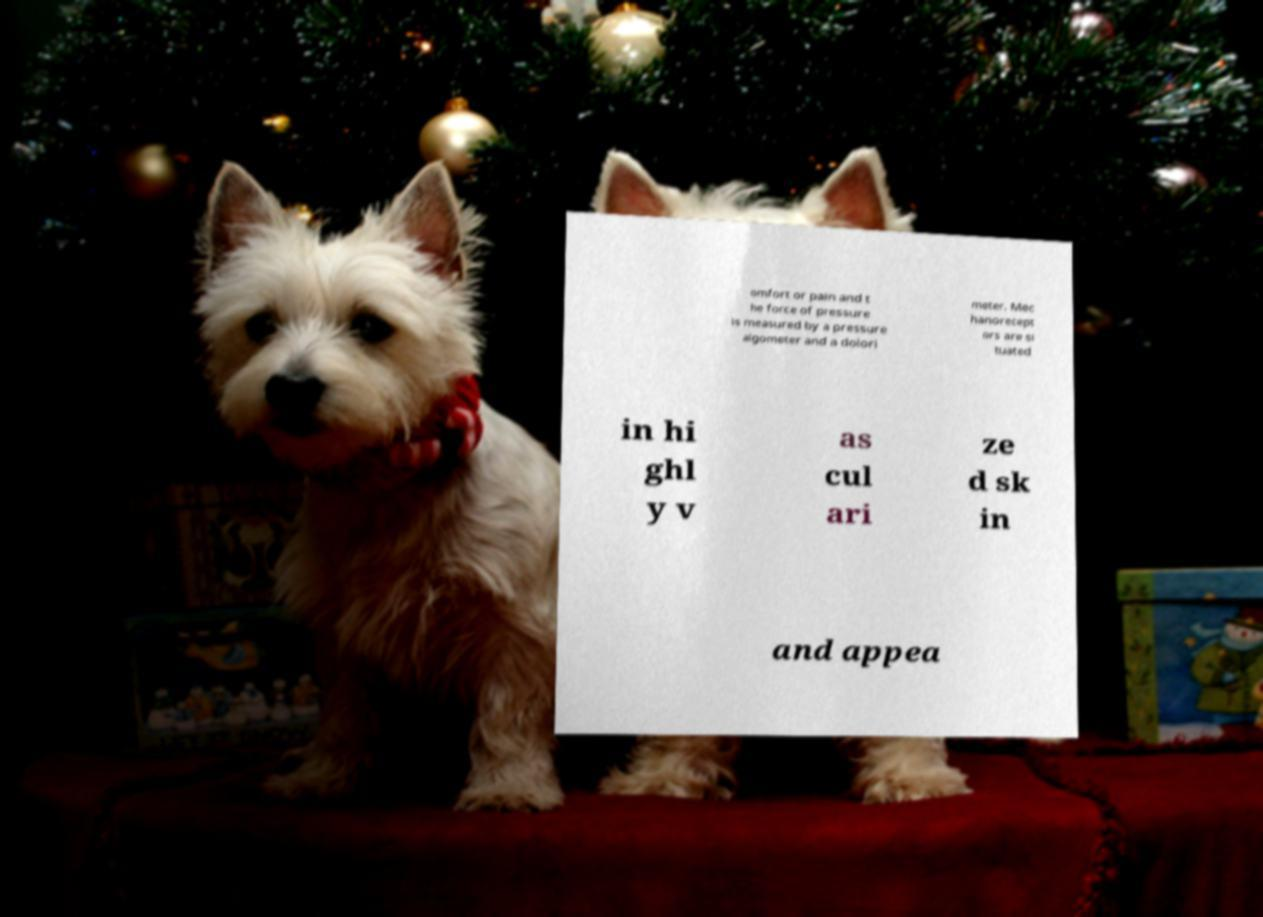Can you accurately transcribe the text from the provided image for me? omfort or pain and t he force of pressure is measured by a pressure algometer and a dolori meter. Mec hanorecept ors are si tuated in hi ghl y v as cul ari ze d sk in and appea 